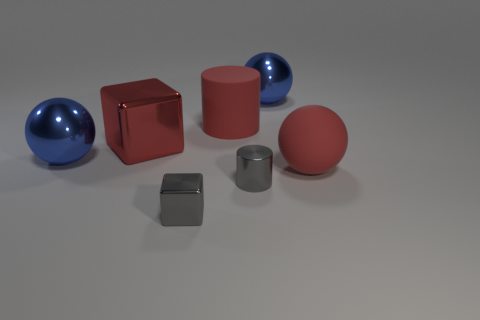The metal thing that is the same color as the small shiny cylinder is what shape?
Ensure brevity in your answer.  Cube. Are there any things that have the same material as the gray cylinder?
Ensure brevity in your answer.  Yes. What is the shape of the red metallic thing?
Make the answer very short. Cube. How many gray metallic cubes are there?
Keep it short and to the point. 1. There is a big metallic ball that is left of the large blue metal thing behind the red rubber cylinder; what is its color?
Give a very brief answer. Blue. The matte cylinder that is the same size as the rubber sphere is what color?
Your response must be concise. Red. Is there a metal thing of the same color as the small metallic block?
Provide a succinct answer. Yes. Is there a rubber cylinder?
Provide a short and direct response. Yes. The tiny gray metallic object behind the small block has what shape?
Your answer should be very brief. Cylinder. How many large blue shiny balls are in front of the red cube and behind the big cylinder?
Your answer should be compact. 0. 